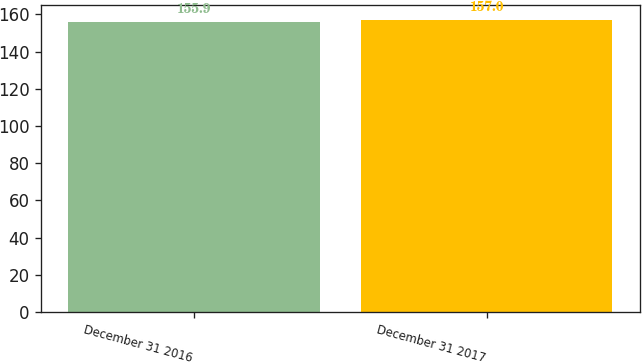<chart> <loc_0><loc_0><loc_500><loc_500><bar_chart><fcel>December 31 2016<fcel>December 31 2017<nl><fcel>155.9<fcel>157<nl></chart> 